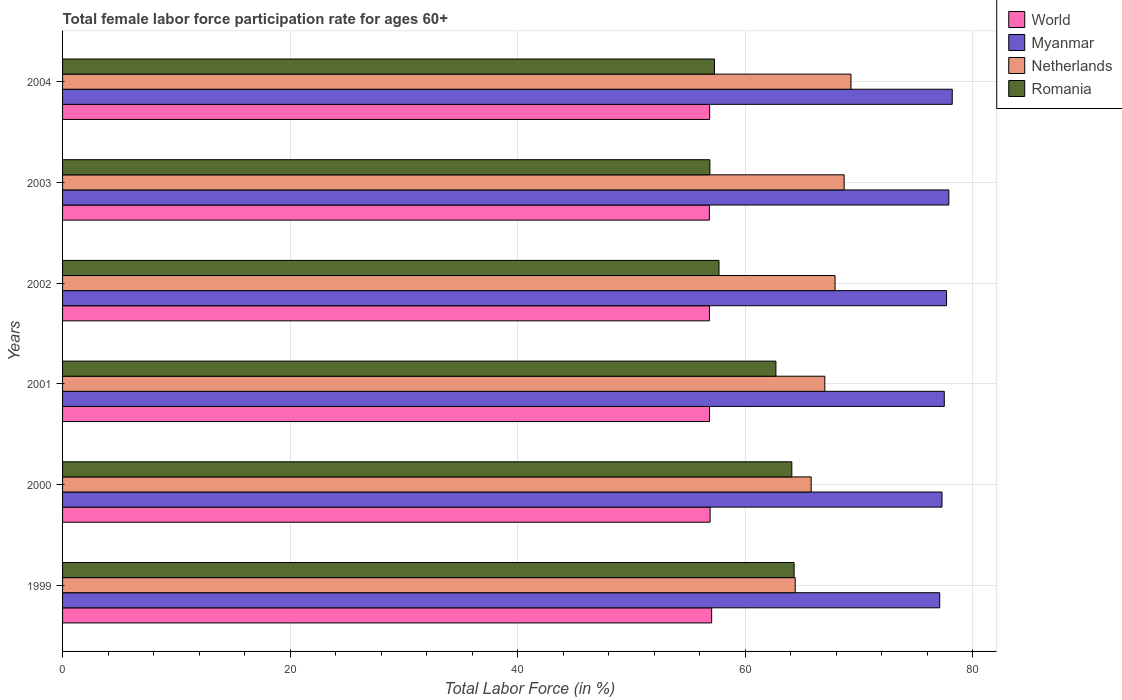How many different coloured bars are there?
Make the answer very short. 4. How many groups of bars are there?
Your response must be concise. 6. Are the number of bars per tick equal to the number of legend labels?
Keep it short and to the point. Yes. Are the number of bars on each tick of the Y-axis equal?
Your answer should be very brief. Yes. What is the label of the 6th group of bars from the top?
Provide a succinct answer. 1999. What is the female labor force participation rate in Romania in 2003?
Your response must be concise. 56.9. Across all years, what is the maximum female labor force participation rate in World?
Your response must be concise. 57.05. Across all years, what is the minimum female labor force participation rate in Netherlands?
Your answer should be very brief. 64.4. What is the total female labor force participation rate in Myanmar in the graph?
Provide a succinct answer. 465.7. What is the difference between the female labor force participation rate in Myanmar in 1999 and that in 2001?
Offer a terse response. -0.4. What is the difference between the female labor force participation rate in World in 2004 and the female labor force participation rate in Netherlands in 1999?
Make the answer very short. -7.52. What is the average female labor force participation rate in Myanmar per year?
Provide a succinct answer. 77.62. In the year 2002, what is the difference between the female labor force participation rate in Romania and female labor force participation rate in World?
Give a very brief answer. 0.84. What is the ratio of the female labor force participation rate in Romania in 2001 to that in 2002?
Your answer should be compact. 1.09. Is the difference between the female labor force participation rate in Romania in 2003 and 2004 greater than the difference between the female labor force participation rate in World in 2003 and 2004?
Ensure brevity in your answer.  No. What is the difference between the highest and the second highest female labor force participation rate in Myanmar?
Make the answer very short. 0.3. What is the difference between the highest and the lowest female labor force participation rate in Romania?
Provide a succinct answer. 7.4. In how many years, is the female labor force participation rate in Myanmar greater than the average female labor force participation rate in Myanmar taken over all years?
Keep it short and to the point. 3. Is the sum of the female labor force participation rate in Romania in 1999 and 2004 greater than the maximum female labor force participation rate in Myanmar across all years?
Ensure brevity in your answer.  Yes. What does the 3rd bar from the bottom in 2004 represents?
Your response must be concise. Netherlands. How many years are there in the graph?
Provide a short and direct response. 6. What is the difference between two consecutive major ticks on the X-axis?
Ensure brevity in your answer.  20. Are the values on the major ticks of X-axis written in scientific E-notation?
Ensure brevity in your answer.  No. Where does the legend appear in the graph?
Offer a very short reply. Top right. What is the title of the graph?
Your answer should be very brief. Total female labor force participation rate for ages 60+. What is the label or title of the X-axis?
Offer a terse response. Total Labor Force (in %). What is the label or title of the Y-axis?
Give a very brief answer. Years. What is the Total Labor Force (in %) in World in 1999?
Offer a very short reply. 57.05. What is the Total Labor Force (in %) in Myanmar in 1999?
Your answer should be very brief. 77.1. What is the Total Labor Force (in %) in Netherlands in 1999?
Offer a terse response. 64.4. What is the Total Labor Force (in %) in Romania in 1999?
Offer a terse response. 64.3. What is the Total Labor Force (in %) of World in 2000?
Provide a succinct answer. 56.92. What is the Total Labor Force (in %) in Myanmar in 2000?
Your answer should be very brief. 77.3. What is the Total Labor Force (in %) in Netherlands in 2000?
Your answer should be very brief. 65.8. What is the Total Labor Force (in %) of Romania in 2000?
Offer a terse response. 64.1. What is the Total Labor Force (in %) of World in 2001?
Keep it short and to the point. 56.87. What is the Total Labor Force (in %) of Myanmar in 2001?
Provide a succinct answer. 77.5. What is the Total Labor Force (in %) of Netherlands in 2001?
Offer a very short reply. 67. What is the Total Labor Force (in %) in Romania in 2001?
Give a very brief answer. 62.7. What is the Total Labor Force (in %) in World in 2002?
Your answer should be very brief. 56.86. What is the Total Labor Force (in %) of Myanmar in 2002?
Keep it short and to the point. 77.7. What is the Total Labor Force (in %) of Netherlands in 2002?
Keep it short and to the point. 67.9. What is the Total Labor Force (in %) of Romania in 2002?
Ensure brevity in your answer.  57.7. What is the Total Labor Force (in %) of World in 2003?
Your answer should be compact. 56.85. What is the Total Labor Force (in %) in Myanmar in 2003?
Your answer should be compact. 77.9. What is the Total Labor Force (in %) in Netherlands in 2003?
Your answer should be very brief. 68.7. What is the Total Labor Force (in %) of Romania in 2003?
Ensure brevity in your answer.  56.9. What is the Total Labor Force (in %) in World in 2004?
Give a very brief answer. 56.88. What is the Total Labor Force (in %) of Myanmar in 2004?
Your answer should be very brief. 78.2. What is the Total Labor Force (in %) in Netherlands in 2004?
Keep it short and to the point. 69.3. What is the Total Labor Force (in %) of Romania in 2004?
Keep it short and to the point. 57.3. Across all years, what is the maximum Total Labor Force (in %) of World?
Your answer should be compact. 57.05. Across all years, what is the maximum Total Labor Force (in %) of Myanmar?
Your answer should be compact. 78.2. Across all years, what is the maximum Total Labor Force (in %) of Netherlands?
Provide a short and direct response. 69.3. Across all years, what is the maximum Total Labor Force (in %) in Romania?
Give a very brief answer. 64.3. Across all years, what is the minimum Total Labor Force (in %) in World?
Offer a terse response. 56.85. Across all years, what is the minimum Total Labor Force (in %) in Myanmar?
Ensure brevity in your answer.  77.1. Across all years, what is the minimum Total Labor Force (in %) of Netherlands?
Keep it short and to the point. 64.4. Across all years, what is the minimum Total Labor Force (in %) of Romania?
Ensure brevity in your answer.  56.9. What is the total Total Labor Force (in %) of World in the graph?
Your answer should be very brief. 341.42. What is the total Total Labor Force (in %) in Myanmar in the graph?
Keep it short and to the point. 465.7. What is the total Total Labor Force (in %) of Netherlands in the graph?
Your answer should be compact. 403.1. What is the total Total Labor Force (in %) of Romania in the graph?
Offer a very short reply. 363. What is the difference between the Total Labor Force (in %) in World in 1999 and that in 2000?
Offer a very short reply. 0.14. What is the difference between the Total Labor Force (in %) in Myanmar in 1999 and that in 2000?
Your answer should be very brief. -0.2. What is the difference between the Total Labor Force (in %) of World in 1999 and that in 2001?
Make the answer very short. 0.19. What is the difference between the Total Labor Force (in %) of Netherlands in 1999 and that in 2001?
Offer a very short reply. -2.6. What is the difference between the Total Labor Force (in %) in Romania in 1999 and that in 2001?
Your response must be concise. 1.6. What is the difference between the Total Labor Force (in %) of World in 1999 and that in 2002?
Offer a terse response. 0.19. What is the difference between the Total Labor Force (in %) in Myanmar in 1999 and that in 2002?
Make the answer very short. -0.6. What is the difference between the Total Labor Force (in %) in Netherlands in 1999 and that in 2002?
Make the answer very short. -3.5. What is the difference between the Total Labor Force (in %) in Romania in 1999 and that in 2002?
Offer a very short reply. 6.6. What is the difference between the Total Labor Force (in %) of World in 1999 and that in 2003?
Ensure brevity in your answer.  0.2. What is the difference between the Total Labor Force (in %) in Romania in 1999 and that in 2003?
Give a very brief answer. 7.4. What is the difference between the Total Labor Force (in %) in World in 1999 and that in 2004?
Give a very brief answer. 0.18. What is the difference between the Total Labor Force (in %) of Myanmar in 1999 and that in 2004?
Offer a terse response. -1.1. What is the difference between the Total Labor Force (in %) in Netherlands in 1999 and that in 2004?
Provide a short and direct response. -4.9. What is the difference between the Total Labor Force (in %) in Romania in 1999 and that in 2004?
Provide a succinct answer. 7. What is the difference between the Total Labor Force (in %) of World in 2000 and that in 2001?
Your response must be concise. 0.05. What is the difference between the Total Labor Force (in %) of Myanmar in 2000 and that in 2001?
Your answer should be very brief. -0.2. What is the difference between the Total Labor Force (in %) of World in 2000 and that in 2002?
Make the answer very short. 0.06. What is the difference between the Total Labor Force (in %) in World in 2000 and that in 2003?
Provide a succinct answer. 0.06. What is the difference between the Total Labor Force (in %) in Myanmar in 2000 and that in 2003?
Keep it short and to the point. -0.6. What is the difference between the Total Labor Force (in %) of Romania in 2000 and that in 2003?
Make the answer very short. 7.2. What is the difference between the Total Labor Force (in %) in Netherlands in 2000 and that in 2004?
Make the answer very short. -3.5. What is the difference between the Total Labor Force (in %) of Romania in 2000 and that in 2004?
Provide a short and direct response. 6.8. What is the difference between the Total Labor Force (in %) of World in 2001 and that in 2002?
Your response must be concise. 0.01. What is the difference between the Total Labor Force (in %) of Myanmar in 2001 and that in 2002?
Your answer should be very brief. -0.2. What is the difference between the Total Labor Force (in %) in Netherlands in 2001 and that in 2002?
Ensure brevity in your answer.  -0.9. What is the difference between the Total Labor Force (in %) of Romania in 2001 and that in 2002?
Offer a very short reply. 5. What is the difference between the Total Labor Force (in %) in World in 2001 and that in 2003?
Keep it short and to the point. 0.01. What is the difference between the Total Labor Force (in %) in World in 2001 and that in 2004?
Offer a very short reply. -0.01. What is the difference between the Total Labor Force (in %) in Myanmar in 2001 and that in 2004?
Offer a terse response. -0.7. What is the difference between the Total Labor Force (in %) of Netherlands in 2001 and that in 2004?
Offer a very short reply. -2.3. What is the difference between the Total Labor Force (in %) of World in 2002 and that in 2003?
Offer a terse response. 0.01. What is the difference between the Total Labor Force (in %) of Netherlands in 2002 and that in 2003?
Offer a very short reply. -0.8. What is the difference between the Total Labor Force (in %) in Romania in 2002 and that in 2003?
Provide a short and direct response. 0.8. What is the difference between the Total Labor Force (in %) in World in 2002 and that in 2004?
Your answer should be compact. -0.02. What is the difference between the Total Labor Force (in %) of Romania in 2002 and that in 2004?
Give a very brief answer. 0.4. What is the difference between the Total Labor Force (in %) in World in 2003 and that in 2004?
Keep it short and to the point. -0.02. What is the difference between the Total Labor Force (in %) in Netherlands in 2003 and that in 2004?
Your answer should be very brief. -0.6. What is the difference between the Total Labor Force (in %) in World in 1999 and the Total Labor Force (in %) in Myanmar in 2000?
Offer a terse response. -20.25. What is the difference between the Total Labor Force (in %) in World in 1999 and the Total Labor Force (in %) in Netherlands in 2000?
Give a very brief answer. -8.75. What is the difference between the Total Labor Force (in %) in World in 1999 and the Total Labor Force (in %) in Romania in 2000?
Give a very brief answer. -7.05. What is the difference between the Total Labor Force (in %) of Myanmar in 1999 and the Total Labor Force (in %) of Netherlands in 2000?
Offer a very short reply. 11.3. What is the difference between the Total Labor Force (in %) of World in 1999 and the Total Labor Force (in %) of Myanmar in 2001?
Make the answer very short. -20.45. What is the difference between the Total Labor Force (in %) of World in 1999 and the Total Labor Force (in %) of Netherlands in 2001?
Your response must be concise. -9.95. What is the difference between the Total Labor Force (in %) of World in 1999 and the Total Labor Force (in %) of Romania in 2001?
Offer a very short reply. -5.65. What is the difference between the Total Labor Force (in %) of Netherlands in 1999 and the Total Labor Force (in %) of Romania in 2001?
Your answer should be compact. 1.7. What is the difference between the Total Labor Force (in %) of World in 1999 and the Total Labor Force (in %) of Myanmar in 2002?
Offer a terse response. -20.65. What is the difference between the Total Labor Force (in %) of World in 1999 and the Total Labor Force (in %) of Netherlands in 2002?
Give a very brief answer. -10.85. What is the difference between the Total Labor Force (in %) in World in 1999 and the Total Labor Force (in %) in Romania in 2002?
Provide a short and direct response. -0.65. What is the difference between the Total Labor Force (in %) of Myanmar in 1999 and the Total Labor Force (in %) of Netherlands in 2002?
Your response must be concise. 9.2. What is the difference between the Total Labor Force (in %) in Netherlands in 1999 and the Total Labor Force (in %) in Romania in 2002?
Your answer should be compact. 6.7. What is the difference between the Total Labor Force (in %) of World in 1999 and the Total Labor Force (in %) of Myanmar in 2003?
Provide a short and direct response. -20.85. What is the difference between the Total Labor Force (in %) of World in 1999 and the Total Labor Force (in %) of Netherlands in 2003?
Your response must be concise. -11.65. What is the difference between the Total Labor Force (in %) of World in 1999 and the Total Labor Force (in %) of Romania in 2003?
Your response must be concise. 0.15. What is the difference between the Total Labor Force (in %) in Myanmar in 1999 and the Total Labor Force (in %) in Romania in 2003?
Give a very brief answer. 20.2. What is the difference between the Total Labor Force (in %) of World in 1999 and the Total Labor Force (in %) of Myanmar in 2004?
Provide a succinct answer. -21.15. What is the difference between the Total Labor Force (in %) of World in 1999 and the Total Labor Force (in %) of Netherlands in 2004?
Make the answer very short. -12.25. What is the difference between the Total Labor Force (in %) of World in 1999 and the Total Labor Force (in %) of Romania in 2004?
Give a very brief answer. -0.25. What is the difference between the Total Labor Force (in %) of Myanmar in 1999 and the Total Labor Force (in %) of Netherlands in 2004?
Your response must be concise. 7.8. What is the difference between the Total Labor Force (in %) of Myanmar in 1999 and the Total Labor Force (in %) of Romania in 2004?
Keep it short and to the point. 19.8. What is the difference between the Total Labor Force (in %) of World in 2000 and the Total Labor Force (in %) of Myanmar in 2001?
Give a very brief answer. -20.58. What is the difference between the Total Labor Force (in %) in World in 2000 and the Total Labor Force (in %) in Netherlands in 2001?
Your answer should be very brief. -10.08. What is the difference between the Total Labor Force (in %) in World in 2000 and the Total Labor Force (in %) in Romania in 2001?
Offer a terse response. -5.78. What is the difference between the Total Labor Force (in %) in Myanmar in 2000 and the Total Labor Force (in %) in Netherlands in 2001?
Your response must be concise. 10.3. What is the difference between the Total Labor Force (in %) of Myanmar in 2000 and the Total Labor Force (in %) of Romania in 2001?
Keep it short and to the point. 14.6. What is the difference between the Total Labor Force (in %) in Netherlands in 2000 and the Total Labor Force (in %) in Romania in 2001?
Offer a very short reply. 3.1. What is the difference between the Total Labor Force (in %) in World in 2000 and the Total Labor Force (in %) in Myanmar in 2002?
Offer a very short reply. -20.78. What is the difference between the Total Labor Force (in %) in World in 2000 and the Total Labor Force (in %) in Netherlands in 2002?
Provide a short and direct response. -10.98. What is the difference between the Total Labor Force (in %) in World in 2000 and the Total Labor Force (in %) in Romania in 2002?
Keep it short and to the point. -0.78. What is the difference between the Total Labor Force (in %) in Myanmar in 2000 and the Total Labor Force (in %) in Netherlands in 2002?
Provide a short and direct response. 9.4. What is the difference between the Total Labor Force (in %) in Myanmar in 2000 and the Total Labor Force (in %) in Romania in 2002?
Ensure brevity in your answer.  19.6. What is the difference between the Total Labor Force (in %) of Netherlands in 2000 and the Total Labor Force (in %) of Romania in 2002?
Make the answer very short. 8.1. What is the difference between the Total Labor Force (in %) of World in 2000 and the Total Labor Force (in %) of Myanmar in 2003?
Your answer should be compact. -20.98. What is the difference between the Total Labor Force (in %) of World in 2000 and the Total Labor Force (in %) of Netherlands in 2003?
Give a very brief answer. -11.78. What is the difference between the Total Labor Force (in %) of World in 2000 and the Total Labor Force (in %) of Romania in 2003?
Provide a succinct answer. 0.02. What is the difference between the Total Labor Force (in %) in Myanmar in 2000 and the Total Labor Force (in %) in Romania in 2003?
Offer a very short reply. 20.4. What is the difference between the Total Labor Force (in %) in Netherlands in 2000 and the Total Labor Force (in %) in Romania in 2003?
Your answer should be compact. 8.9. What is the difference between the Total Labor Force (in %) of World in 2000 and the Total Labor Force (in %) of Myanmar in 2004?
Give a very brief answer. -21.28. What is the difference between the Total Labor Force (in %) of World in 2000 and the Total Labor Force (in %) of Netherlands in 2004?
Your answer should be compact. -12.38. What is the difference between the Total Labor Force (in %) of World in 2000 and the Total Labor Force (in %) of Romania in 2004?
Your answer should be very brief. -0.38. What is the difference between the Total Labor Force (in %) of World in 2001 and the Total Labor Force (in %) of Myanmar in 2002?
Your answer should be compact. -20.83. What is the difference between the Total Labor Force (in %) of World in 2001 and the Total Labor Force (in %) of Netherlands in 2002?
Your answer should be compact. -11.03. What is the difference between the Total Labor Force (in %) in World in 2001 and the Total Labor Force (in %) in Romania in 2002?
Offer a very short reply. -0.83. What is the difference between the Total Labor Force (in %) in Myanmar in 2001 and the Total Labor Force (in %) in Romania in 2002?
Your answer should be very brief. 19.8. What is the difference between the Total Labor Force (in %) of Netherlands in 2001 and the Total Labor Force (in %) of Romania in 2002?
Your answer should be very brief. 9.3. What is the difference between the Total Labor Force (in %) in World in 2001 and the Total Labor Force (in %) in Myanmar in 2003?
Provide a succinct answer. -21.03. What is the difference between the Total Labor Force (in %) in World in 2001 and the Total Labor Force (in %) in Netherlands in 2003?
Offer a very short reply. -11.83. What is the difference between the Total Labor Force (in %) in World in 2001 and the Total Labor Force (in %) in Romania in 2003?
Give a very brief answer. -0.03. What is the difference between the Total Labor Force (in %) of Myanmar in 2001 and the Total Labor Force (in %) of Romania in 2003?
Make the answer very short. 20.6. What is the difference between the Total Labor Force (in %) of World in 2001 and the Total Labor Force (in %) of Myanmar in 2004?
Keep it short and to the point. -21.33. What is the difference between the Total Labor Force (in %) in World in 2001 and the Total Labor Force (in %) in Netherlands in 2004?
Offer a very short reply. -12.43. What is the difference between the Total Labor Force (in %) of World in 2001 and the Total Labor Force (in %) of Romania in 2004?
Provide a succinct answer. -0.43. What is the difference between the Total Labor Force (in %) in Myanmar in 2001 and the Total Labor Force (in %) in Romania in 2004?
Offer a terse response. 20.2. What is the difference between the Total Labor Force (in %) in World in 2002 and the Total Labor Force (in %) in Myanmar in 2003?
Your response must be concise. -21.04. What is the difference between the Total Labor Force (in %) in World in 2002 and the Total Labor Force (in %) in Netherlands in 2003?
Provide a short and direct response. -11.84. What is the difference between the Total Labor Force (in %) in World in 2002 and the Total Labor Force (in %) in Romania in 2003?
Provide a succinct answer. -0.04. What is the difference between the Total Labor Force (in %) of Myanmar in 2002 and the Total Labor Force (in %) of Netherlands in 2003?
Your answer should be very brief. 9. What is the difference between the Total Labor Force (in %) of Myanmar in 2002 and the Total Labor Force (in %) of Romania in 2003?
Your response must be concise. 20.8. What is the difference between the Total Labor Force (in %) in World in 2002 and the Total Labor Force (in %) in Myanmar in 2004?
Keep it short and to the point. -21.34. What is the difference between the Total Labor Force (in %) of World in 2002 and the Total Labor Force (in %) of Netherlands in 2004?
Keep it short and to the point. -12.44. What is the difference between the Total Labor Force (in %) in World in 2002 and the Total Labor Force (in %) in Romania in 2004?
Provide a short and direct response. -0.44. What is the difference between the Total Labor Force (in %) of Myanmar in 2002 and the Total Labor Force (in %) of Netherlands in 2004?
Your answer should be very brief. 8.4. What is the difference between the Total Labor Force (in %) in Myanmar in 2002 and the Total Labor Force (in %) in Romania in 2004?
Provide a short and direct response. 20.4. What is the difference between the Total Labor Force (in %) of World in 2003 and the Total Labor Force (in %) of Myanmar in 2004?
Your answer should be compact. -21.35. What is the difference between the Total Labor Force (in %) of World in 2003 and the Total Labor Force (in %) of Netherlands in 2004?
Provide a short and direct response. -12.45. What is the difference between the Total Labor Force (in %) of World in 2003 and the Total Labor Force (in %) of Romania in 2004?
Your answer should be compact. -0.45. What is the difference between the Total Labor Force (in %) in Myanmar in 2003 and the Total Labor Force (in %) in Romania in 2004?
Offer a terse response. 20.6. What is the average Total Labor Force (in %) of World per year?
Your answer should be compact. 56.9. What is the average Total Labor Force (in %) in Myanmar per year?
Offer a terse response. 77.62. What is the average Total Labor Force (in %) in Netherlands per year?
Offer a very short reply. 67.18. What is the average Total Labor Force (in %) in Romania per year?
Give a very brief answer. 60.5. In the year 1999, what is the difference between the Total Labor Force (in %) in World and Total Labor Force (in %) in Myanmar?
Provide a short and direct response. -20.05. In the year 1999, what is the difference between the Total Labor Force (in %) in World and Total Labor Force (in %) in Netherlands?
Your answer should be compact. -7.35. In the year 1999, what is the difference between the Total Labor Force (in %) in World and Total Labor Force (in %) in Romania?
Offer a very short reply. -7.25. In the year 1999, what is the difference between the Total Labor Force (in %) of Myanmar and Total Labor Force (in %) of Netherlands?
Offer a terse response. 12.7. In the year 1999, what is the difference between the Total Labor Force (in %) in Netherlands and Total Labor Force (in %) in Romania?
Ensure brevity in your answer.  0.1. In the year 2000, what is the difference between the Total Labor Force (in %) of World and Total Labor Force (in %) of Myanmar?
Your response must be concise. -20.38. In the year 2000, what is the difference between the Total Labor Force (in %) in World and Total Labor Force (in %) in Netherlands?
Make the answer very short. -8.88. In the year 2000, what is the difference between the Total Labor Force (in %) of World and Total Labor Force (in %) of Romania?
Offer a very short reply. -7.18. In the year 2000, what is the difference between the Total Labor Force (in %) of Netherlands and Total Labor Force (in %) of Romania?
Give a very brief answer. 1.7. In the year 2001, what is the difference between the Total Labor Force (in %) in World and Total Labor Force (in %) in Myanmar?
Offer a very short reply. -20.63. In the year 2001, what is the difference between the Total Labor Force (in %) of World and Total Labor Force (in %) of Netherlands?
Ensure brevity in your answer.  -10.13. In the year 2001, what is the difference between the Total Labor Force (in %) of World and Total Labor Force (in %) of Romania?
Your response must be concise. -5.83. In the year 2001, what is the difference between the Total Labor Force (in %) of Myanmar and Total Labor Force (in %) of Netherlands?
Make the answer very short. 10.5. In the year 2001, what is the difference between the Total Labor Force (in %) in Netherlands and Total Labor Force (in %) in Romania?
Provide a short and direct response. 4.3. In the year 2002, what is the difference between the Total Labor Force (in %) of World and Total Labor Force (in %) of Myanmar?
Provide a succinct answer. -20.84. In the year 2002, what is the difference between the Total Labor Force (in %) of World and Total Labor Force (in %) of Netherlands?
Give a very brief answer. -11.04. In the year 2002, what is the difference between the Total Labor Force (in %) in World and Total Labor Force (in %) in Romania?
Ensure brevity in your answer.  -0.84. In the year 2002, what is the difference between the Total Labor Force (in %) in Myanmar and Total Labor Force (in %) in Netherlands?
Your answer should be very brief. 9.8. In the year 2003, what is the difference between the Total Labor Force (in %) of World and Total Labor Force (in %) of Myanmar?
Offer a very short reply. -21.05. In the year 2003, what is the difference between the Total Labor Force (in %) of World and Total Labor Force (in %) of Netherlands?
Make the answer very short. -11.85. In the year 2003, what is the difference between the Total Labor Force (in %) in World and Total Labor Force (in %) in Romania?
Make the answer very short. -0.05. In the year 2004, what is the difference between the Total Labor Force (in %) of World and Total Labor Force (in %) of Myanmar?
Give a very brief answer. -21.32. In the year 2004, what is the difference between the Total Labor Force (in %) of World and Total Labor Force (in %) of Netherlands?
Offer a very short reply. -12.42. In the year 2004, what is the difference between the Total Labor Force (in %) of World and Total Labor Force (in %) of Romania?
Make the answer very short. -0.42. In the year 2004, what is the difference between the Total Labor Force (in %) of Myanmar and Total Labor Force (in %) of Romania?
Provide a succinct answer. 20.9. What is the ratio of the Total Labor Force (in %) in World in 1999 to that in 2000?
Your answer should be very brief. 1. What is the ratio of the Total Labor Force (in %) of Netherlands in 1999 to that in 2000?
Offer a terse response. 0.98. What is the ratio of the Total Labor Force (in %) in Romania in 1999 to that in 2000?
Provide a succinct answer. 1. What is the ratio of the Total Labor Force (in %) in World in 1999 to that in 2001?
Your answer should be very brief. 1. What is the ratio of the Total Labor Force (in %) of Myanmar in 1999 to that in 2001?
Provide a short and direct response. 0.99. What is the ratio of the Total Labor Force (in %) in Netherlands in 1999 to that in 2001?
Make the answer very short. 0.96. What is the ratio of the Total Labor Force (in %) of Romania in 1999 to that in 2001?
Offer a very short reply. 1.03. What is the ratio of the Total Labor Force (in %) of Netherlands in 1999 to that in 2002?
Your response must be concise. 0.95. What is the ratio of the Total Labor Force (in %) in Romania in 1999 to that in 2002?
Keep it short and to the point. 1.11. What is the ratio of the Total Labor Force (in %) in Netherlands in 1999 to that in 2003?
Offer a terse response. 0.94. What is the ratio of the Total Labor Force (in %) in Romania in 1999 to that in 2003?
Ensure brevity in your answer.  1.13. What is the ratio of the Total Labor Force (in %) in Myanmar in 1999 to that in 2004?
Ensure brevity in your answer.  0.99. What is the ratio of the Total Labor Force (in %) of Netherlands in 1999 to that in 2004?
Keep it short and to the point. 0.93. What is the ratio of the Total Labor Force (in %) of Romania in 1999 to that in 2004?
Your answer should be very brief. 1.12. What is the ratio of the Total Labor Force (in %) in World in 2000 to that in 2001?
Provide a succinct answer. 1. What is the ratio of the Total Labor Force (in %) in Netherlands in 2000 to that in 2001?
Offer a terse response. 0.98. What is the ratio of the Total Labor Force (in %) of Romania in 2000 to that in 2001?
Give a very brief answer. 1.02. What is the ratio of the Total Labor Force (in %) in Netherlands in 2000 to that in 2002?
Provide a short and direct response. 0.97. What is the ratio of the Total Labor Force (in %) of Romania in 2000 to that in 2002?
Your answer should be compact. 1.11. What is the ratio of the Total Labor Force (in %) in Myanmar in 2000 to that in 2003?
Offer a very short reply. 0.99. What is the ratio of the Total Labor Force (in %) of Netherlands in 2000 to that in 2003?
Your response must be concise. 0.96. What is the ratio of the Total Labor Force (in %) in Romania in 2000 to that in 2003?
Make the answer very short. 1.13. What is the ratio of the Total Labor Force (in %) of Myanmar in 2000 to that in 2004?
Offer a very short reply. 0.99. What is the ratio of the Total Labor Force (in %) of Netherlands in 2000 to that in 2004?
Ensure brevity in your answer.  0.95. What is the ratio of the Total Labor Force (in %) of Romania in 2000 to that in 2004?
Make the answer very short. 1.12. What is the ratio of the Total Labor Force (in %) in World in 2001 to that in 2002?
Your answer should be very brief. 1. What is the ratio of the Total Labor Force (in %) in Netherlands in 2001 to that in 2002?
Your answer should be compact. 0.99. What is the ratio of the Total Labor Force (in %) of Romania in 2001 to that in 2002?
Provide a succinct answer. 1.09. What is the ratio of the Total Labor Force (in %) in World in 2001 to that in 2003?
Offer a very short reply. 1. What is the ratio of the Total Labor Force (in %) in Myanmar in 2001 to that in 2003?
Keep it short and to the point. 0.99. What is the ratio of the Total Labor Force (in %) in Netherlands in 2001 to that in 2003?
Give a very brief answer. 0.98. What is the ratio of the Total Labor Force (in %) in Romania in 2001 to that in 2003?
Provide a succinct answer. 1.1. What is the ratio of the Total Labor Force (in %) of Myanmar in 2001 to that in 2004?
Provide a succinct answer. 0.99. What is the ratio of the Total Labor Force (in %) of Netherlands in 2001 to that in 2004?
Ensure brevity in your answer.  0.97. What is the ratio of the Total Labor Force (in %) of Romania in 2001 to that in 2004?
Offer a very short reply. 1.09. What is the ratio of the Total Labor Force (in %) of World in 2002 to that in 2003?
Your answer should be compact. 1. What is the ratio of the Total Labor Force (in %) of Myanmar in 2002 to that in 2003?
Provide a succinct answer. 1. What is the ratio of the Total Labor Force (in %) in Netherlands in 2002 to that in 2003?
Provide a succinct answer. 0.99. What is the ratio of the Total Labor Force (in %) in Romania in 2002 to that in 2003?
Give a very brief answer. 1.01. What is the ratio of the Total Labor Force (in %) in World in 2002 to that in 2004?
Give a very brief answer. 1. What is the ratio of the Total Labor Force (in %) of Myanmar in 2002 to that in 2004?
Provide a succinct answer. 0.99. What is the ratio of the Total Labor Force (in %) in Netherlands in 2002 to that in 2004?
Offer a terse response. 0.98. What is the ratio of the Total Labor Force (in %) in Romania in 2002 to that in 2004?
Give a very brief answer. 1.01. What is the ratio of the Total Labor Force (in %) of Myanmar in 2003 to that in 2004?
Offer a very short reply. 1. What is the difference between the highest and the second highest Total Labor Force (in %) of World?
Make the answer very short. 0.14. What is the difference between the highest and the second highest Total Labor Force (in %) in Myanmar?
Make the answer very short. 0.3. What is the difference between the highest and the lowest Total Labor Force (in %) of World?
Offer a terse response. 0.2. What is the difference between the highest and the lowest Total Labor Force (in %) of Romania?
Offer a terse response. 7.4. 